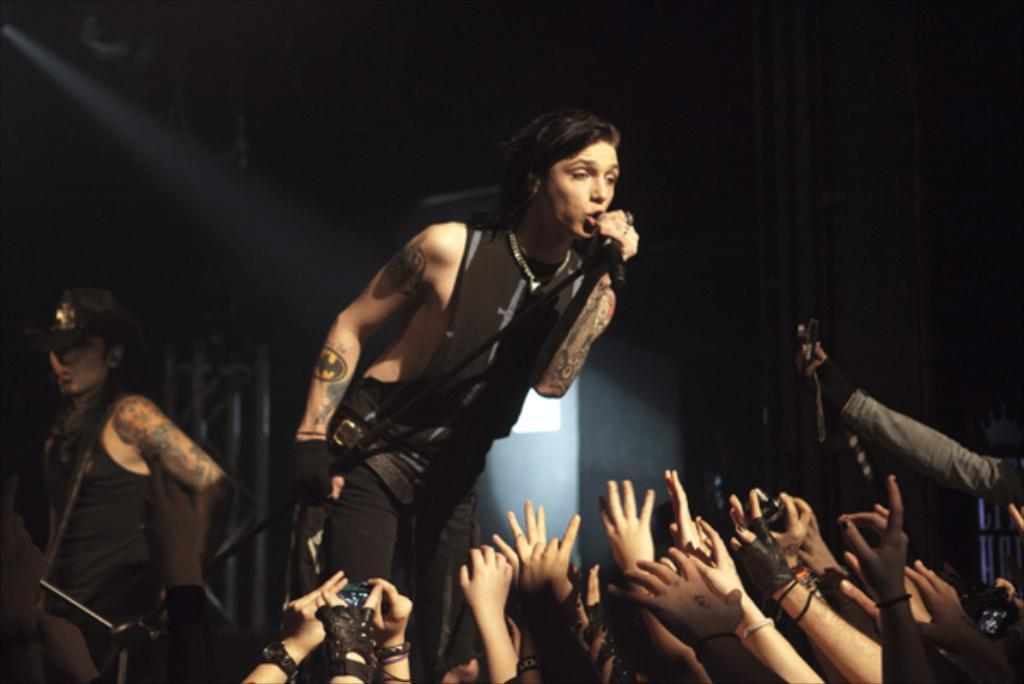Who is the main subject in the image? There is a woman in the image. What is the woman doing in the image? The woman is singing on a microphone. Are there any other people present in the image? Yes, there are people present in the image. What verse is the woman reciting in the image? The image does not show the woman reciting a verse; she is singing on a microphone. 